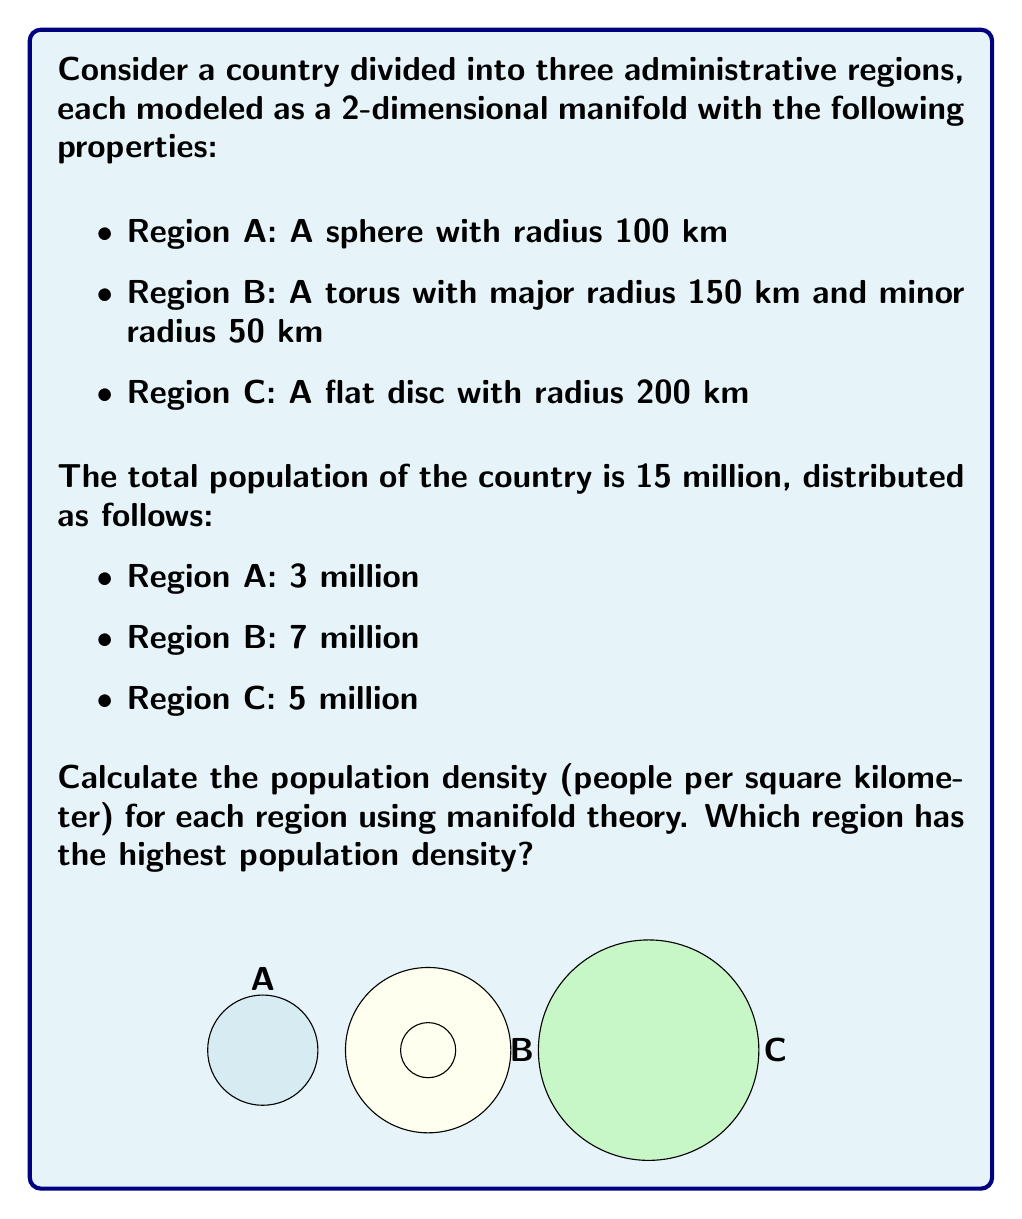Give your solution to this math problem. To solve this problem, we need to calculate the surface area of each region using manifold theory and then divide the population by the area to get the population density.

1. Region A (Sphere):
   The surface area of a sphere is given by $A = 4\pi r^2$
   $A_A = 4\pi (100)^2 = 125,663.71$ km²
   Population density = $\frac{3,000,000}{125,663.71} = 23.87$ people/km²

2. Region B (Torus):
   The surface area of a torus is given by $A = 4\pi^2 R r$, where $R$ is the major radius and $r$ is the minor radius
   $A_B = 4\pi^2 (150)(50) = 296,088.38$ km²
   Population density = $\frac{7,000,000}{296,088.38} = 23.64$ people/km²

3. Region C (Flat Disc):
   The area of a disc is given by $A = \pi r^2$
   $A_C = \pi (200)^2 = 125,663.71$ km²
   Population density = $\frac{5,000,000}{125,663.71} = 39.79$ people/km²

Comparing the population densities:
Region A: 23.87 people/km²
Region B: 23.64 people/km²
Region C: 39.79 people/km²

Region C (the flat disc) has the highest population density.
Answer: Region C: 39.79 people/km² 